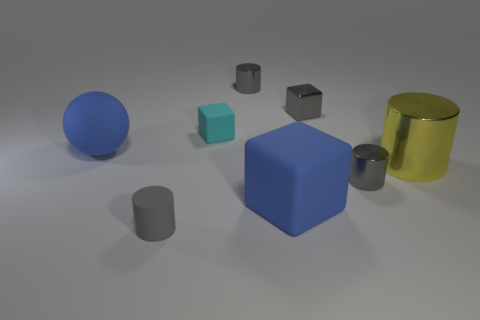What colors are the objects in the image? The objects in the image consist of various colors. There's a large blue sphere, a large blue cube, a small cyan cube, two grey cylinders of different sizes, a small dark grey cube, and a large metallic golden cylinder. 